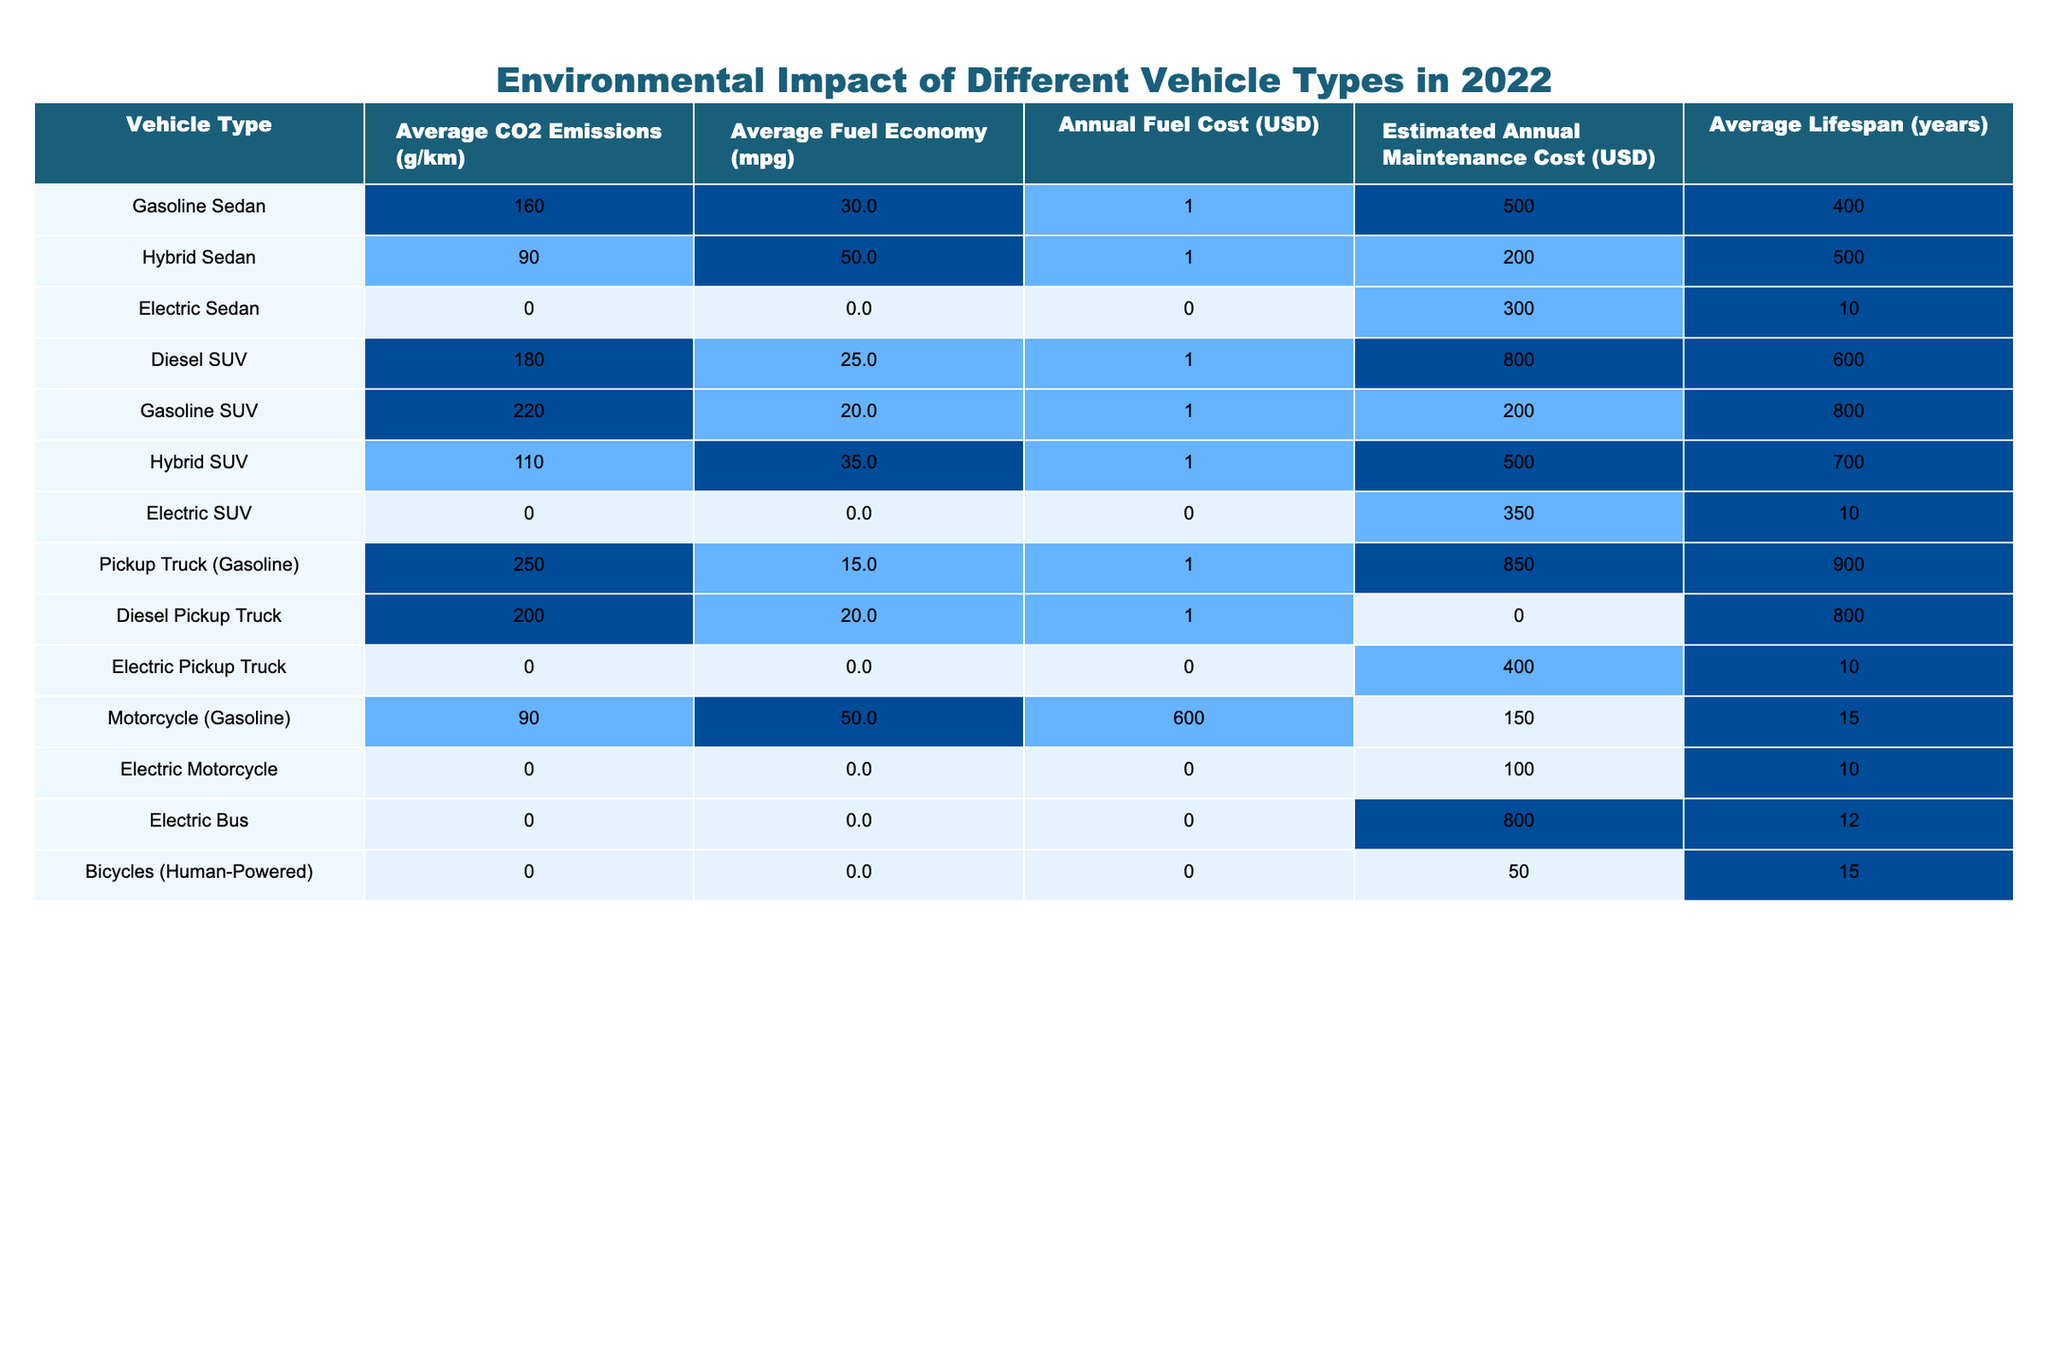What is the average CO2 emissions of hybrid sedans? The table lists hybrid sedans with an average CO2 emissions of 90 g/km.
Answer: 90 g/km Which vehicle type has the lowest average fuel economy? The average fuel economy for vehicles is displayed, and the gasoline pickup truck has the lowest at 15 mpg.
Answer: 15 mpg What vehicle type has the highest annual fuel cost? By comparing the annual fuel costs from the table, the gasoline pickup truck's cost is $1,850, which is the highest.
Answer: $1,850 Are electric sedans and electric SUVs associated with any CO2 emissions? The table indicates both electric sedans and electric SUVs have 0 g/km CO2 emissions, confirming they do not emit CO2.
Answer: Yes What is the difference in average CO2 emissions between gasoline SUVs and hybrid SUVs? Gasoline SUVs have an average emissions of 220 g/km, while hybrid SUVs have 110 g/km. The difference is 220 - 110 = 110 g/km.
Answer: 110 g/km Which vehicle type has the highest estimated annual maintenance cost? The table shows that the gasoline pickup truck has the highest estimated annual maintenance cost at $900.
Answer: $900 If we consider hybrid vehicles, what is the average annual fuel cost for hybrid sedans and hybrid SUVs combined? The annual fuel costs for hybrid sedans and hybrid SUVs are $1,200 and $1,500 respectively. The average is calculated as (1,200 + 1,500) / 2 = 1,350.
Answer: $1,350 Is there any vehicle type that costs less than $100 for annual fuel costs? By reviewing the annual fuel costs in the table, electric vehicles have $0 listed, indicating they cost nothing for fuel.
Answer: Yes What is the average lifespan of gasoline vehicles listed in the table? The average lifespan for gasoline sedan (400), gasoline SUV (800), and gasoline pickup truck (900) is calculated by summing 10, 15, and 10 years and dividing by 3, which equals approximately 11.67 years.
Answer: 11.67 years How does the estimated maintenance cost of diesel SUVs compare to that of diesel pickup trucks? Diesel SUVs have an estimated maintenance cost of $600, while diesel pickup trucks have $800. This shows that diesel pickup trucks have a higher maintenance cost by $200.
Answer: $200 